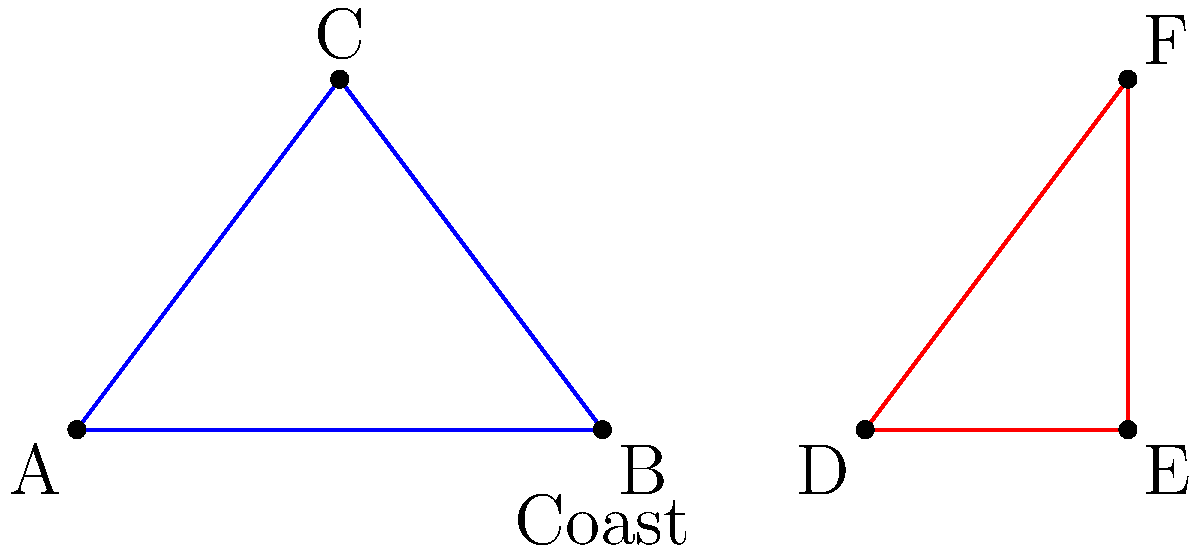Two lifeguard towers are positioned along a coastline, represented by triangular structures ABC and DEF. Given that AB = 6 units, BC = 5 units, AC = 5 units, DE = 3 units, and $\angle BAC = \angle EDF = 90°$, determine if these two structures are congruent. If they are, state the congruence criterion that proves it. To determine if the two triangles are congruent, we need to compare their sides and angles:

1. We know that $\angle BAC = \angle EDF = 90°$, so one angle is the same in both triangles.

2. For triangle ABC:
   - AB = 6 units
   - BC = 5 units
   - AC = 5 units
   This forms a 3-4-5 right triangle, scaled up by a factor of 1.2.

3. For triangle DEF:
   - DE = 3 units
   - We need to find EF and DF

4. Since DEF is also a right triangle with DE = 3, it must be a 3-4-5 right triangle scaled by a factor of 0.6:
   - EF = 4 * 0.6 = 2.4 units
   - DF = 5 * 0.6 = 3 units

5. Comparing the triangles:
   - $\angle BAC = \angle EDF = 90°$
   - AB : DE = 6 : 3 = 2 : 1
   - BC : EF = 5 : 2.4 ≈ 2.08 : 1
   - AC : DF = 5 : 3 ≈ 1.67 : 1

6. The ratios of corresponding sides are not all equal, which means the triangles are not similar, and therefore not congruent.
Answer: Not congruent 